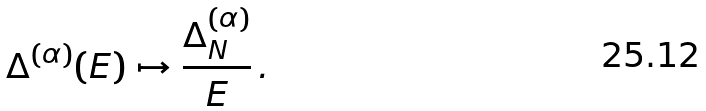<formula> <loc_0><loc_0><loc_500><loc_500>\Delta ^ { ( \alpha ) } ( E ) \mapsto \frac { \Delta _ { N } ^ { ( \alpha ) } } { E } \, .</formula> 